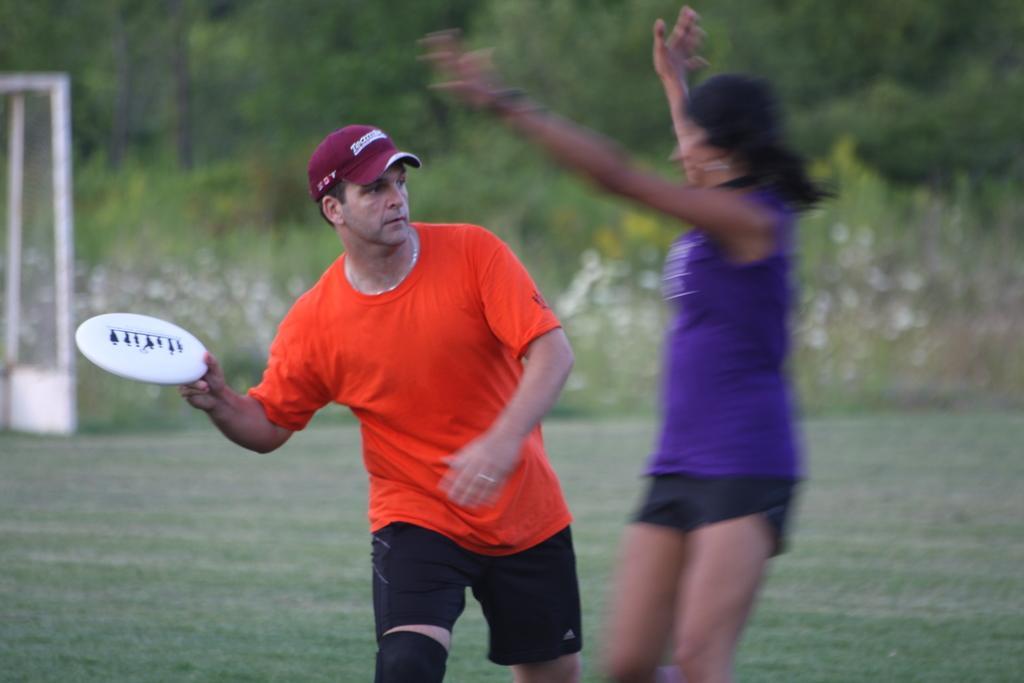Could you give a brief overview of what you see in this image? In this picture I can see there is a man and a woman, the man on top left is wearing an orange shirt, a cap and holding a white color object. There is grass on the floor and there are few plants in the backdrop and there is a net at left side, the backdrop is blurred. 